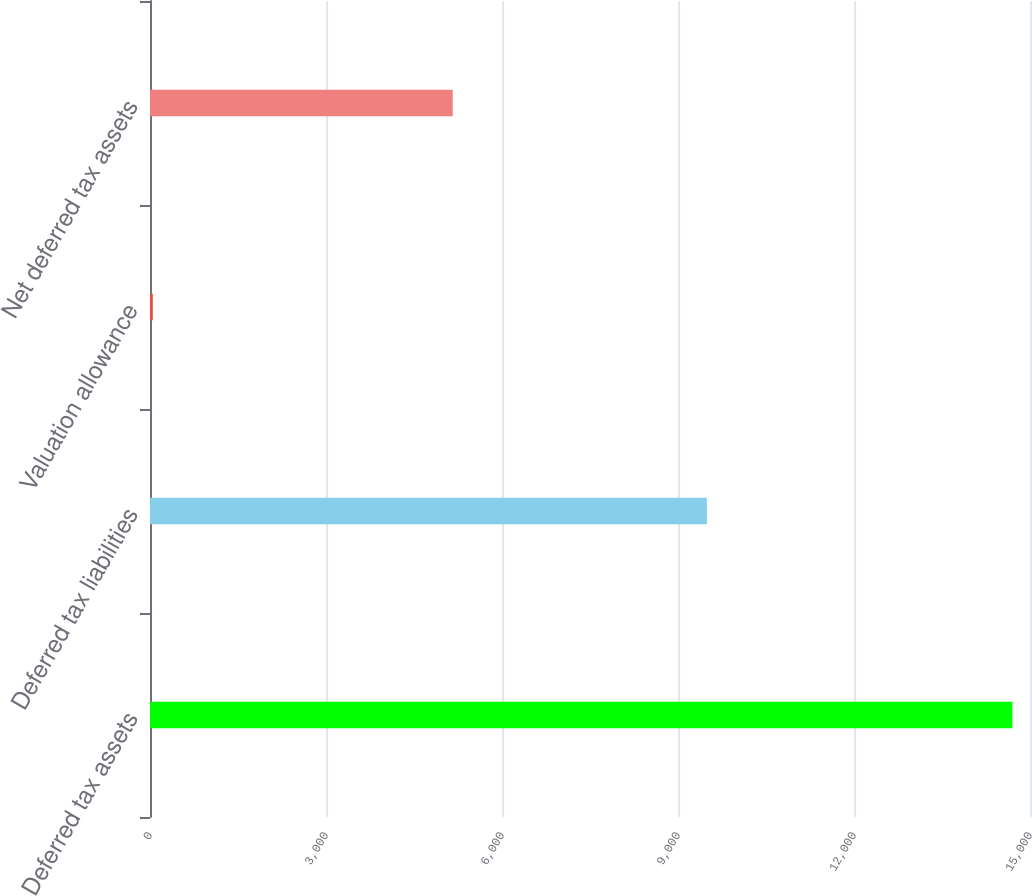<chart> <loc_0><loc_0><loc_500><loc_500><bar_chart><fcel>Deferred tax assets<fcel>Deferred tax liabilities<fcel>Valuation allowance<fcel>Net deferred tax assets<nl><fcel>14700<fcel>9492<fcel>48<fcel>5160<nl></chart> 